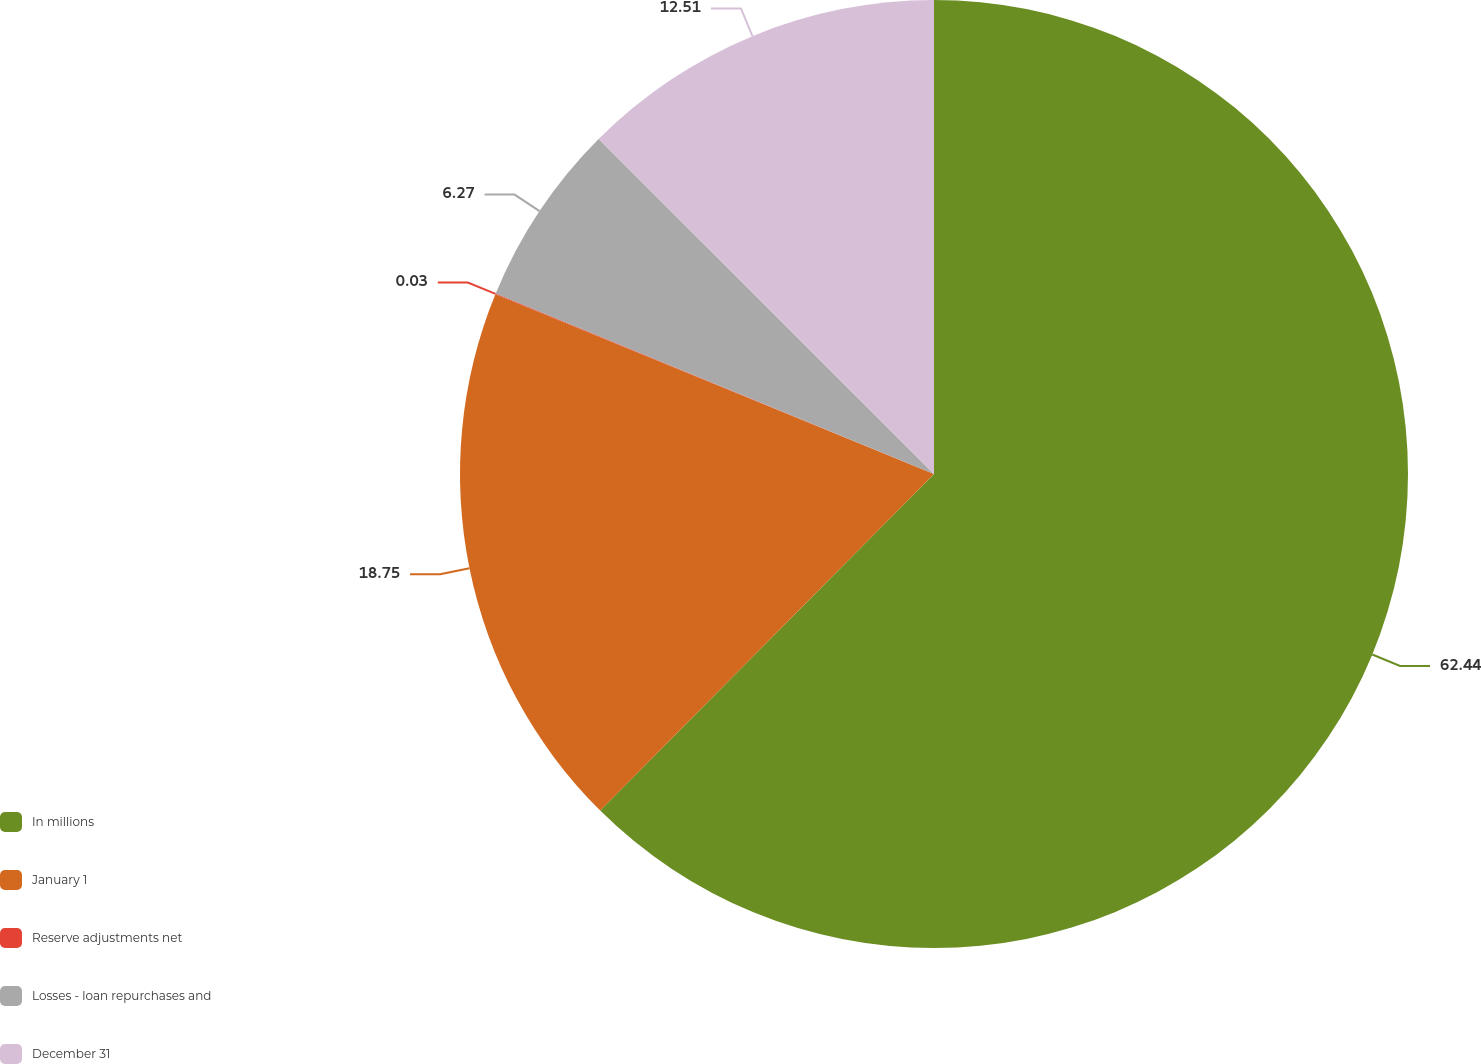<chart> <loc_0><loc_0><loc_500><loc_500><pie_chart><fcel>In millions<fcel>January 1<fcel>Reserve adjustments net<fcel>Losses - loan repurchases and<fcel>December 31<nl><fcel>62.43%<fcel>18.75%<fcel>0.03%<fcel>6.27%<fcel>12.51%<nl></chart> 